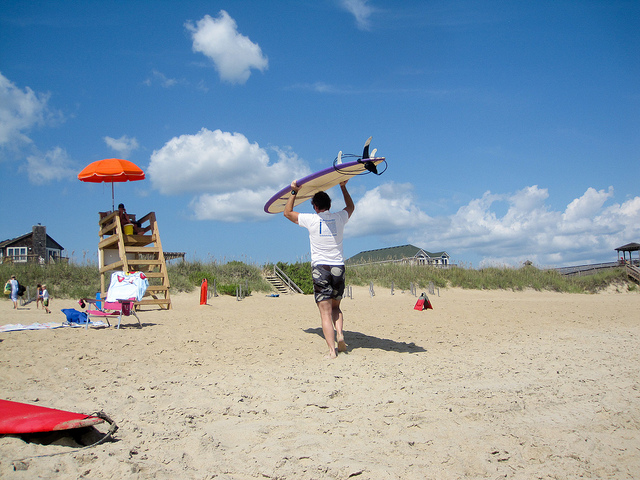Tell me more about the beach environment shown in this picture. The image depicts a typical beach setting with elements that suggest a popular recreational area. There is a lifeguard stand indicating that the area is supervised for safety. The sand appears soft and lighter in color, typical of many sandy beaches. There are also a few beachgoers, umbrellas providing shade, and sparse vegetation in the background which might be part of coastal dunes. Collectively, these features contribute to a serene yet vibrant beachscape, perfect for a variety of beach activities. 